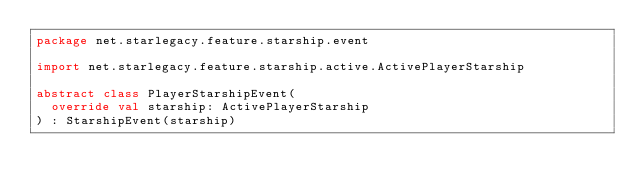<code> <loc_0><loc_0><loc_500><loc_500><_Kotlin_>package net.starlegacy.feature.starship.event

import net.starlegacy.feature.starship.active.ActivePlayerStarship

abstract class PlayerStarshipEvent(
	override val starship: ActivePlayerStarship
) : StarshipEvent(starship)
</code> 